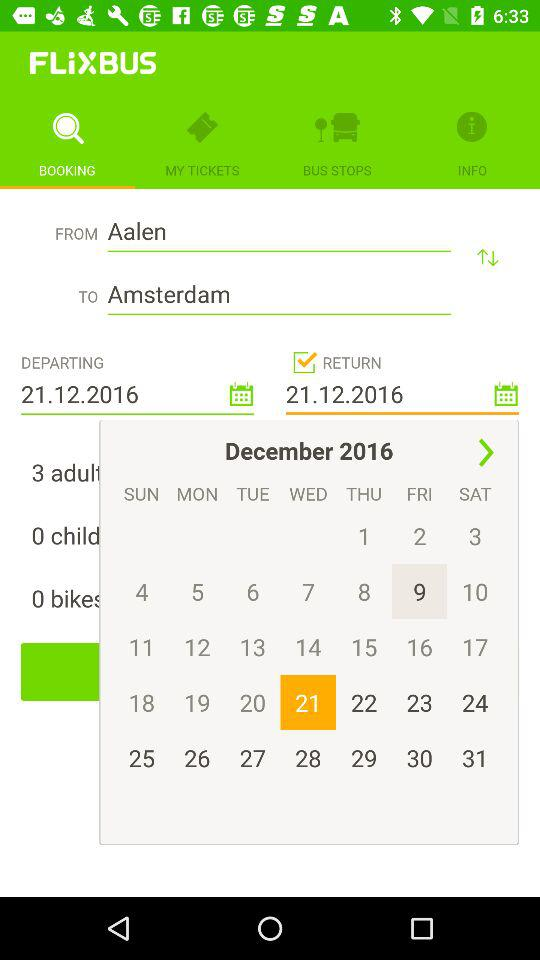What is the destination city name? The destination city name is Amsterdam. 